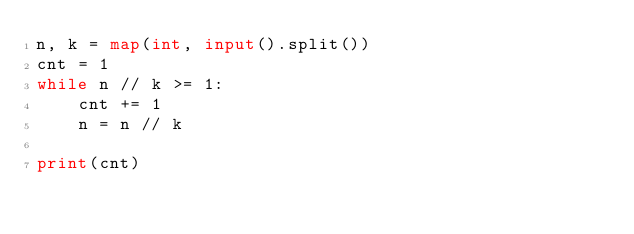<code> <loc_0><loc_0><loc_500><loc_500><_Python_>n, k = map(int, input().split())
cnt = 1
while n // k >= 1:
    cnt += 1
    n = n // k

print(cnt)</code> 